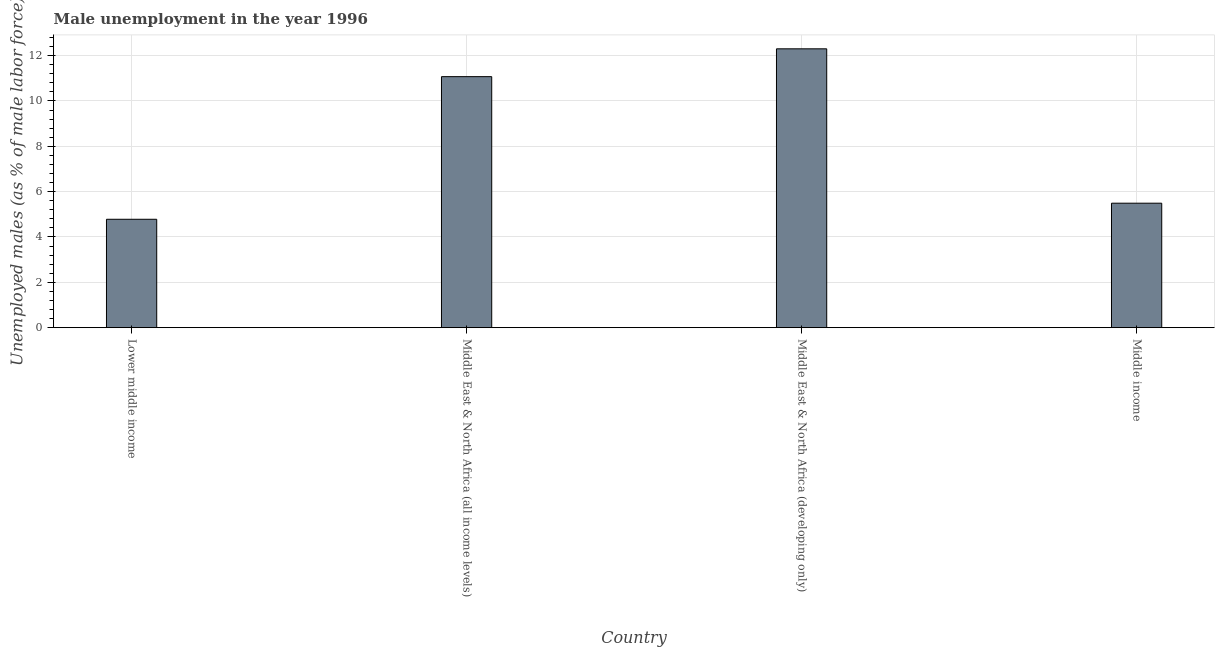Does the graph contain any zero values?
Keep it short and to the point. No. Does the graph contain grids?
Your answer should be very brief. Yes. What is the title of the graph?
Make the answer very short. Male unemployment in the year 1996. What is the label or title of the X-axis?
Keep it short and to the point. Country. What is the label or title of the Y-axis?
Offer a terse response. Unemployed males (as % of male labor force). What is the unemployed males population in Middle income?
Make the answer very short. 5.49. Across all countries, what is the maximum unemployed males population?
Your response must be concise. 12.3. Across all countries, what is the minimum unemployed males population?
Offer a terse response. 4.78. In which country was the unemployed males population maximum?
Offer a terse response. Middle East & North Africa (developing only). In which country was the unemployed males population minimum?
Ensure brevity in your answer.  Lower middle income. What is the sum of the unemployed males population?
Give a very brief answer. 33.64. What is the difference between the unemployed males population in Lower middle income and Middle East & North Africa (all income levels)?
Make the answer very short. -6.29. What is the average unemployed males population per country?
Make the answer very short. 8.41. What is the median unemployed males population?
Give a very brief answer. 8.28. In how many countries, is the unemployed males population greater than 4.4 %?
Provide a short and direct response. 4. What is the ratio of the unemployed males population in Middle East & North Africa (all income levels) to that in Middle income?
Give a very brief answer. 2.02. Is the unemployed males population in Middle East & North Africa (developing only) less than that in Middle income?
Make the answer very short. No. Is the difference between the unemployed males population in Middle East & North Africa (all income levels) and Middle East & North Africa (developing only) greater than the difference between any two countries?
Offer a terse response. No. What is the difference between the highest and the second highest unemployed males population?
Your answer should be very brief. 1.23. What is the difference between the highest and the lowest unemployed males population?
Your answer should be very brief. 7.52. What is the Unemployed males (as % of male labor force) in Lower middle income?
Make the answer very short. 4.78. What is the Unemployed males (as % of male labor force) of Middle East & North Africa (all income levels)?
Offer a terse response. 11.07. What is the Unemployed males (as % of male labor force) in Middle East & North Africa (developing only)?
Make the answer very short. 12.3. What is the Unemployed males (as % of male labor force) in Middle income?
Your answer should be compact. 5.49. What is the difference between the Unemployed males (as % of male labor force) in Lower middle income and Middle East & North Africa (all income levels)?
Your response must be concise. -6.29. What is the difference between the Unemployed males (as % of male labor force) in Lower middle income and Middle East & North Africa (developing only)?
Your response must be concise. -7.52. What is the difference between the Unemployed males (as % of male labor force) in Lower middle income and Middle income?
Offer a very short reply. -0.71. What is the difference between the Unemployed males (as % of male labor force) in Middle East & North Africa (all income levels) and Middle East & North Africa (developing only)?
Your response must be concise. -1.23. What is the difference between the Unemployed males (as % of male labor force) in Middle East & North Africa (all income levels) and Middle income?
Your response must be concise. 5.58. What is the difference between the Unemployed males (as % of male labor force) in Middle East & North Africa (developing only) and Middle income?
Your answer should be very brief. 6.81. What is the ratio of the Unemployed males (as % of male labor force) in Lower middle income to that in Middle East & North Africa (all income levels)?
Your answer should be very brief. 0.43. What is the ratio of the Unemployed males (as % of male labor force) in Lower middle income to that in Middle East & North Africa (developing only)?
Keep it short and to the point. 0.39. What is the ratio of the Unemployed males (as % of male labor force) in Lower middle income to that in Middle income?
Provide a short and direct response. 0.87. What is the ratio of the Unemployed males (as % of male labor force) in Middle East & North Africa (all income levels) to that in Middle East & North Africa (developing only)?
Make the answer very short. 0.9. What is the ratio of the Unemployed males (as % of male labor force) in Middle East & North Africa (all income levels) to that in Middle income?
Your answer should be very brief. 2.02. What is the ratio of the Unemployed males (as % of male labor force) in Middle East & North Africa (developing only) to that in Middle income?
Your response must be concise. 2.24. 